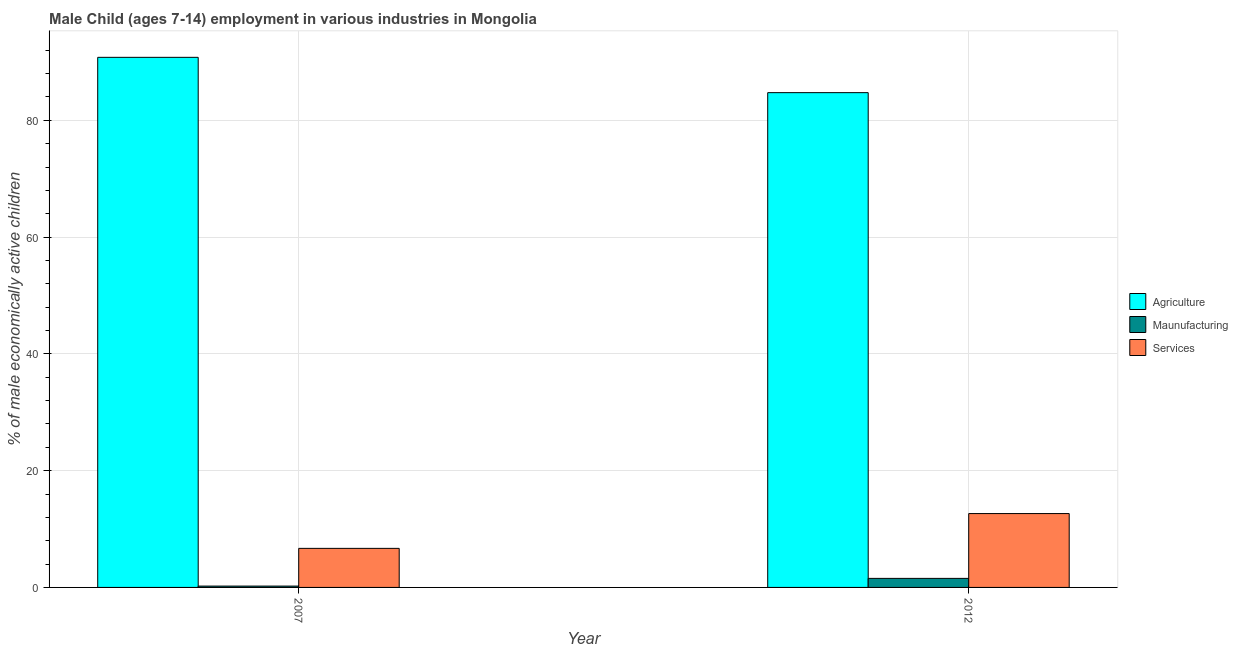How many groups of bars are there?
Provide a short and direct response. 2. Are the number of bars per tick equal to the number of legend labels?
Give a very brief answer. Yes. Are the number of bars on each tick of the X-axis equal?
Give a very brief answer. Yes. In how many cases, is the number of bars for a given year not equal to the number of legend labels?
Offer a very short reply. 0. What is the percentage of economically active children in manufacturing in 2007?
Make the answer very short. 0.23. Across all years, what is the maximum percentage of economically active children in services?
Provide a succinct answer. 12.65. Across all years, what is the minimum percentage of economically active children in agriculture?
Provide a short and direct response. 84.74. What is the total percentage of economically active children in manufacturing in the graph?
Your response must be concise. 1.78. What is the difference between the percentage of economically active children in services in 2007 and that in 2012?
Your answer should be compact. -5.96. What is the difference between the percentage of economically active children in manufacturing in 2007 and the percentage of economically active children in services in 2012?
Ensure brevity in your answer.  -1.32. What is the average percentage of economically active children in services per year?
Your response must be concise. 9.67. What is the ratio of the percentage of economically active children in agriculture in 2007 to that in 2012?
Provide a short and direct response. 1.07. What does the 1st bar from the left in 2012 represents?
Your response must be concise. Agriculture. What does the 2nd bar from the right in 2007 represents?
Make the answer very short. Maunufacturing. Is it the case that in every year, the sum of the percentage of economically active children in agriculture and percentage of economically active children in manufacturing is greater than the percentage of economically active children in services?
Your answer should be very brief. Yes. How many bars are there?
Your answer should be compact. 6. How many years are there in the graph?
Offer a very short reply. 2. Does the graph contain any zero values?
Give a very brief answer. No. Where does the legend appear in the graph?
Your answer should be compact. Center right. How are the legend labels stacked?
Provide a short and direct response. Vertical. What is the title of the graph?
Provide a succinct answer. Male Child (ages 7-14) employment in various industries in Mongolia. What is the label or title of the Y-axis?
Keep it short and to the point. % of male economically active children. What is the % of male economically active children of Agriculture in 2007?
Offer a terse response. 90.79. What is the % of male economically active children of Maunufacturing in 2007?
Offer a terse response. 0.23. What is the % of male economically active children of Services in 2007?
Provide a succinct answer. 6.69. What is the % of male economically active children of Agriculture in 2012?
Keep it short and to the point. 84.74. What is the % of male economically active children in Maunufacturing in 2012?
Provide a short and direct response. 1.55. What is the % of male economically active children in Services in 2012?
Give a very brief answer. 12.65. Across all years, what is the maximum % of male economically active children in Agriculture?
Make the answer very short. 90.79. Across all years, what is the maximum % of male economically active children of Maunufacturing?
Make the answer very short. 1.55. Across all years, what is the maximum % of male economically active children in Services?
Give a very brief answer. 12.65. Across all years, what is the minimum % of male economically active children in Agriculture?
Keep it short and to the point. 84.74. Across all years, what is the minimum % of male economically active children in Maunufacturing?
Ensure brevity in your answer.  0.23. Across all years, what is the minimum % of male economically active children in Services?
Give a very brief answer. 6.69. What is the total % of male economically active children in Agriculture in the graph?
Make the answer very short. 175.53. What is the total % of male economically active children in Maunufacturing in the graph?
Make the answer very short. 1.78. What is the total % of male economically active children in Services in the graph?
Your answer should be compact. 19.34. What is the difference between the % of male economically active children of Agriculture in 2007 and that in 2012?
Keep it short and to the point. 6.05. What is the difference between the % of male economically active children in Maunufacturing in 2007 and that in 2012?
Your answer should be very brief. -1.32. What is the difference between the % of male economically active children of Services in 2007 and that in 2012?
Your answer should be very brief. -5.96. What is the difference between the % of male economically active children of Agriculture in 2007 and the % of male economically active children of Maunufacturing in 2012?
Offer a terse response. 89.24. What is the difference between the % of male economically active children of Agriculture in 2007 and the % of male economically active children of Services in 2012?
Offer a very short reply. 78.14. What is the difference between the % of male economically active children of Maunufacturing in 2007 and the % of male economically active children of Services in 2012?
Keep it short and to the point. -12.42. What is the average % of male economically active children in Agriculture per year?
Your answer should be compact. 87.77. What is the average % of male economically active children of Maunufacturing per year?
Give a very brief answer. 0.89. What is the average % of male economically active children of Services per year?
Ensure brevity in your answer.  9.67. In the year 2007, what is the difference between the % of male economically active children of Agriculture and % of male economically active children of Maunufacturing?
Provide a short and direct response. 90.56. In the year 2007, what is the difference between the % of male economically active children in Agriculture and % of male economically active children in Services?
Your response must be concise. 84.1. In the year 2007, what is the difference between the % of male economically active children in Maunufacturing and % of male economically active children in Services?
Give a very brief answer. -6.46. In the year 2012, what is the difference between the % of male economically active children of Agriculture and % of male economically active children of Maunufacturing?
Ensure brevity in your answer.  83.19. In the year 2012, what is the difference between the % of male economically active children in Agriculture and % of male economically active children in Services?
Your response must be concise. 72.09. What is the ratio of the % of male economically active children of Agriculture in 2007 to that in 2012?
Your answer should be very brief. 1.07. What is the ratio of the % of male economically active children of Maunufacturing in 2007 to that in 2012?
Provide a succinct answer. 0.15. What is the ratio of the % of male economically active children of Services in 2007 to that in 2012?
Your response must be concise. 0.53. What is the difference between the highest and the second highest % of male economically active children of Agriculture?
Keep it short and to the point. 6.05. What is the difference between the highest and the second highest % of male economically active children in Maunufacturing?
Provide a short and direct response. 1.32. What is the difference between the highest and the second highest % of male economically active children of Services?
Give a very brief answer. 5.96. What is the difference between the highest and the lowest % of male economically active children of Agriculture?
Ensure brevity in your answer.  6.05. What is the difference between the highest and the lowest % of male economically active children of Maunufacturing?
Make the answer very short. 1.32. What is the difference between the highest and the lowest % of male economically active children of Services?
Your answer should be very brief. 5.96. 